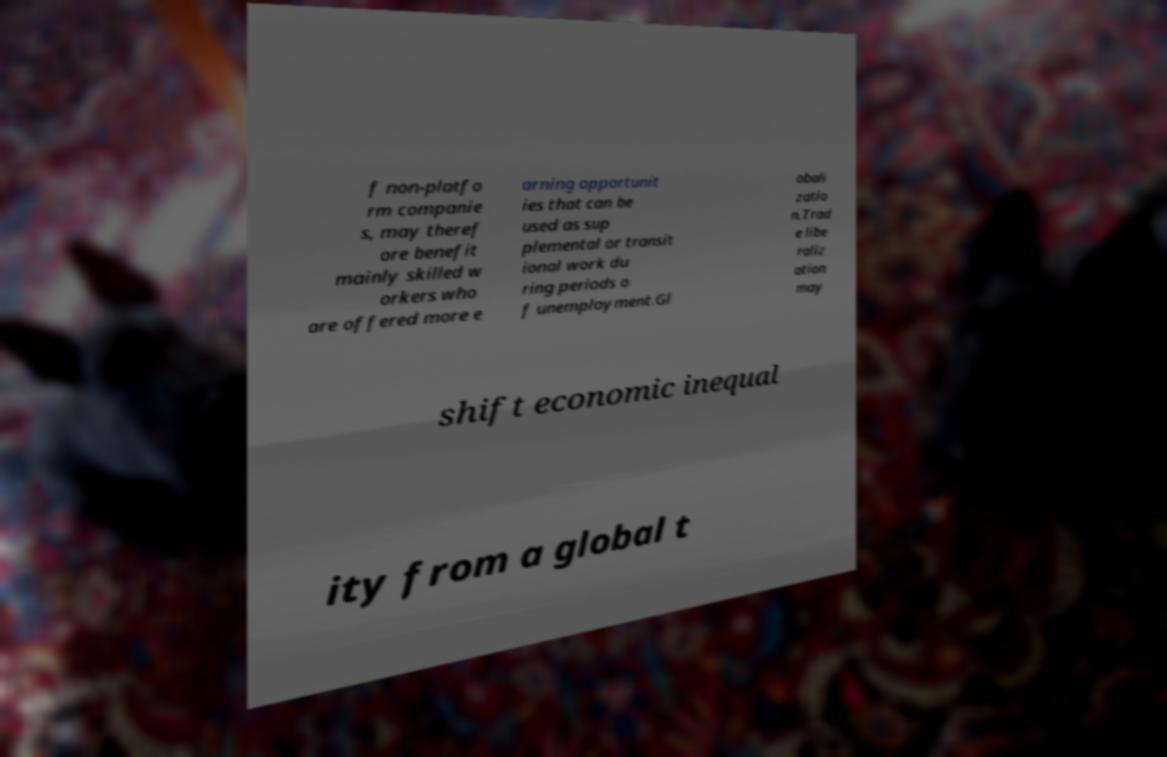Please read and relay the text visible in this image. What does it say? The text in the image appears to be discussing the impact of non-platform companies on skilled workers and the role of trade liberalization in shifting economic inequality. However, due to the quality and angle of the photo, the complete context of the text is not fully visible, and therefore, can't be accurately relayed in its entirety. 